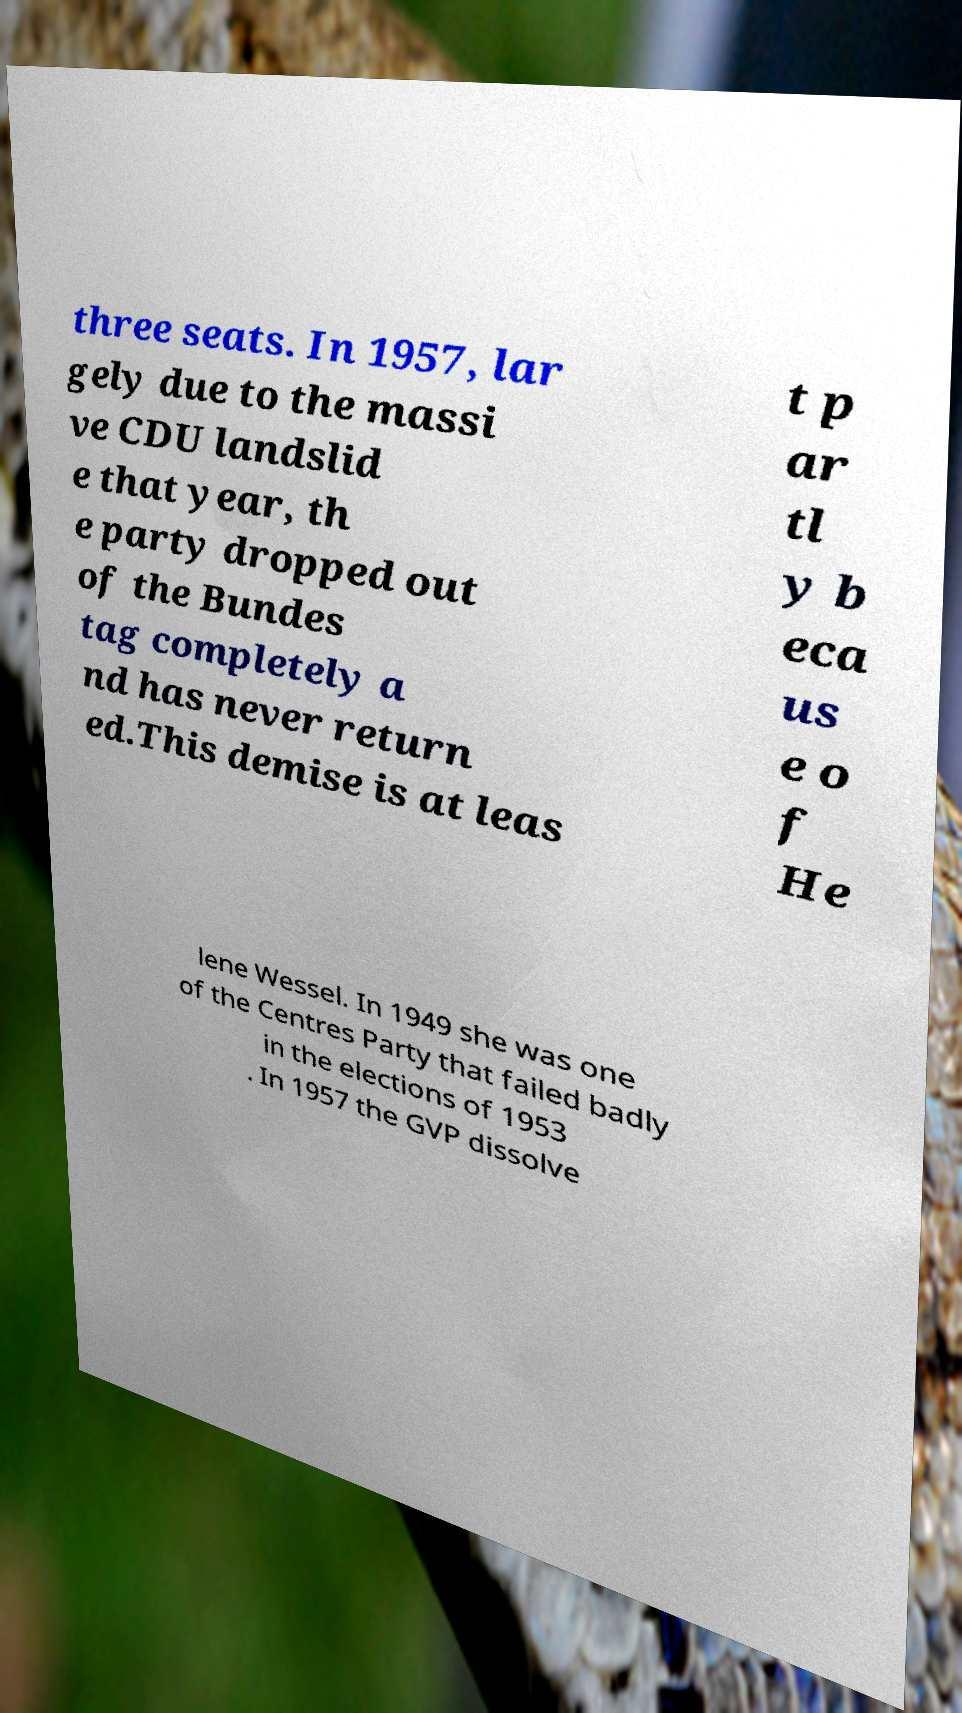Can you read and provide the text displayed in the image?This photo seems to have some interesting text. Can you extract and type it out for me? three seats. In 1957, lar gely due to the massi ve CDU landslid e that year, th e party dropped out of the Bundes tag completely a nd has never return ed.This demise is at leas t p ar tl y b eca us e o f He lene Wessel. In 1949 she was one of the Centres Party that failed badly in the elections of 1953 . In 1957 the GVP dissolve 